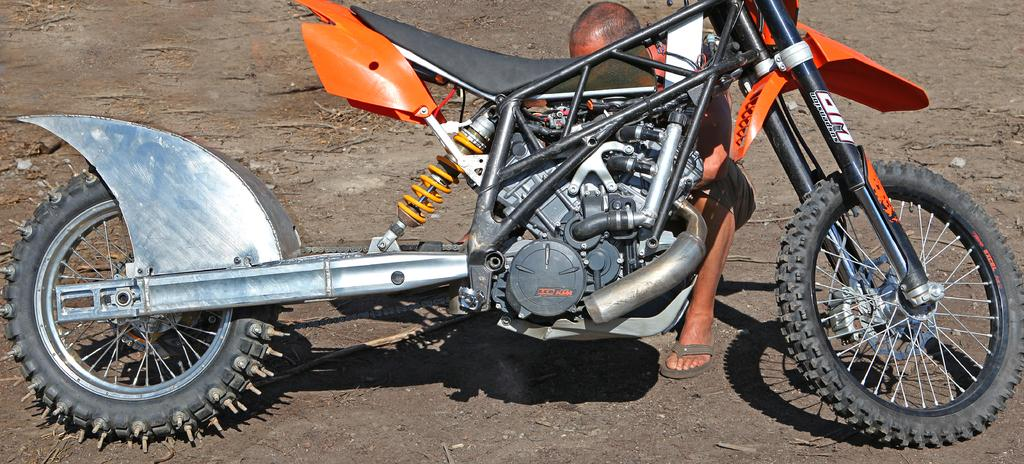What is the main subject of the image? The main subject of the image is a motorcycle. Can you describe the position of the motorcycle in the image? The motorcycle is on the ground in the image. Is there anyone associated with the motorcycle in the image? Yes, there is a person sitting behind the motorcycle. How many lizards can be seen crawling on the motorcycle in the image? There are no lizards present in the image; it only features a motorcycle and a person sitting behind it. 